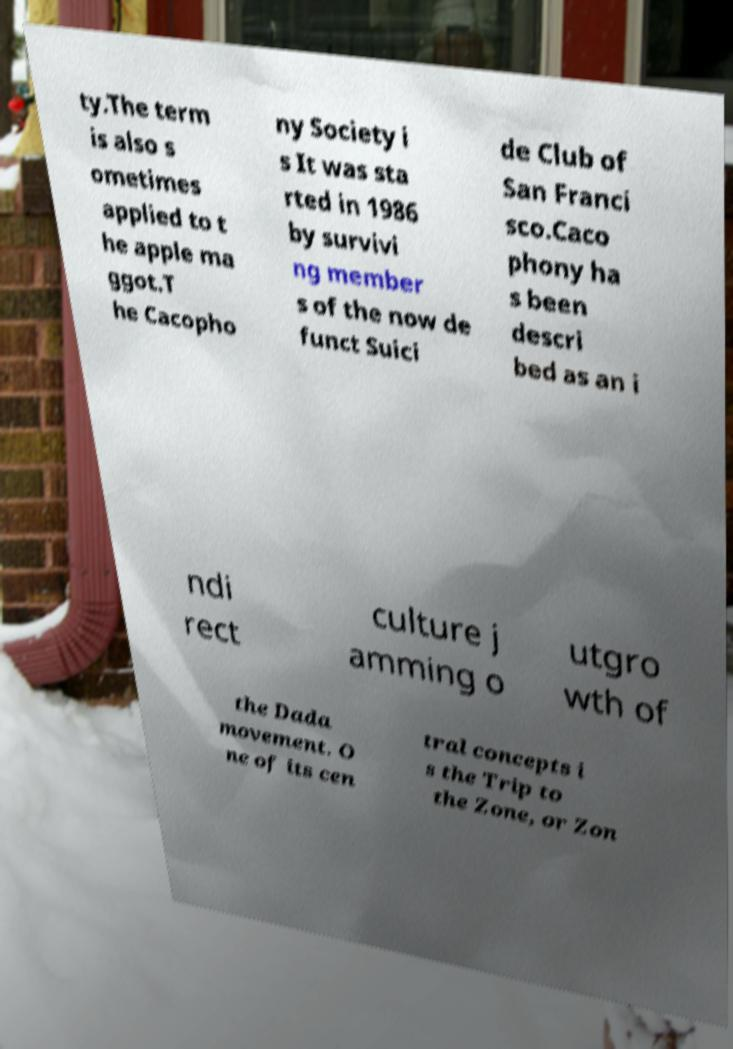Can you read and provide the text displayed in the image?This photo seems to have some interesting text. Can you extract and type it out for me? ty.The term is also s ometimes applied to t he apple ma ggot.T he Cacopho ny Society i s It was sta rted in 1986 by survivi ng member s of the now de funct Suici de Club of San Franci sco.Caco phony ha s been descri bed as an i ndi rect culture j amming o utgro wth of the Dada movement. O ne of its cen tral concepts i s the Trip to the Zone, or Zon 